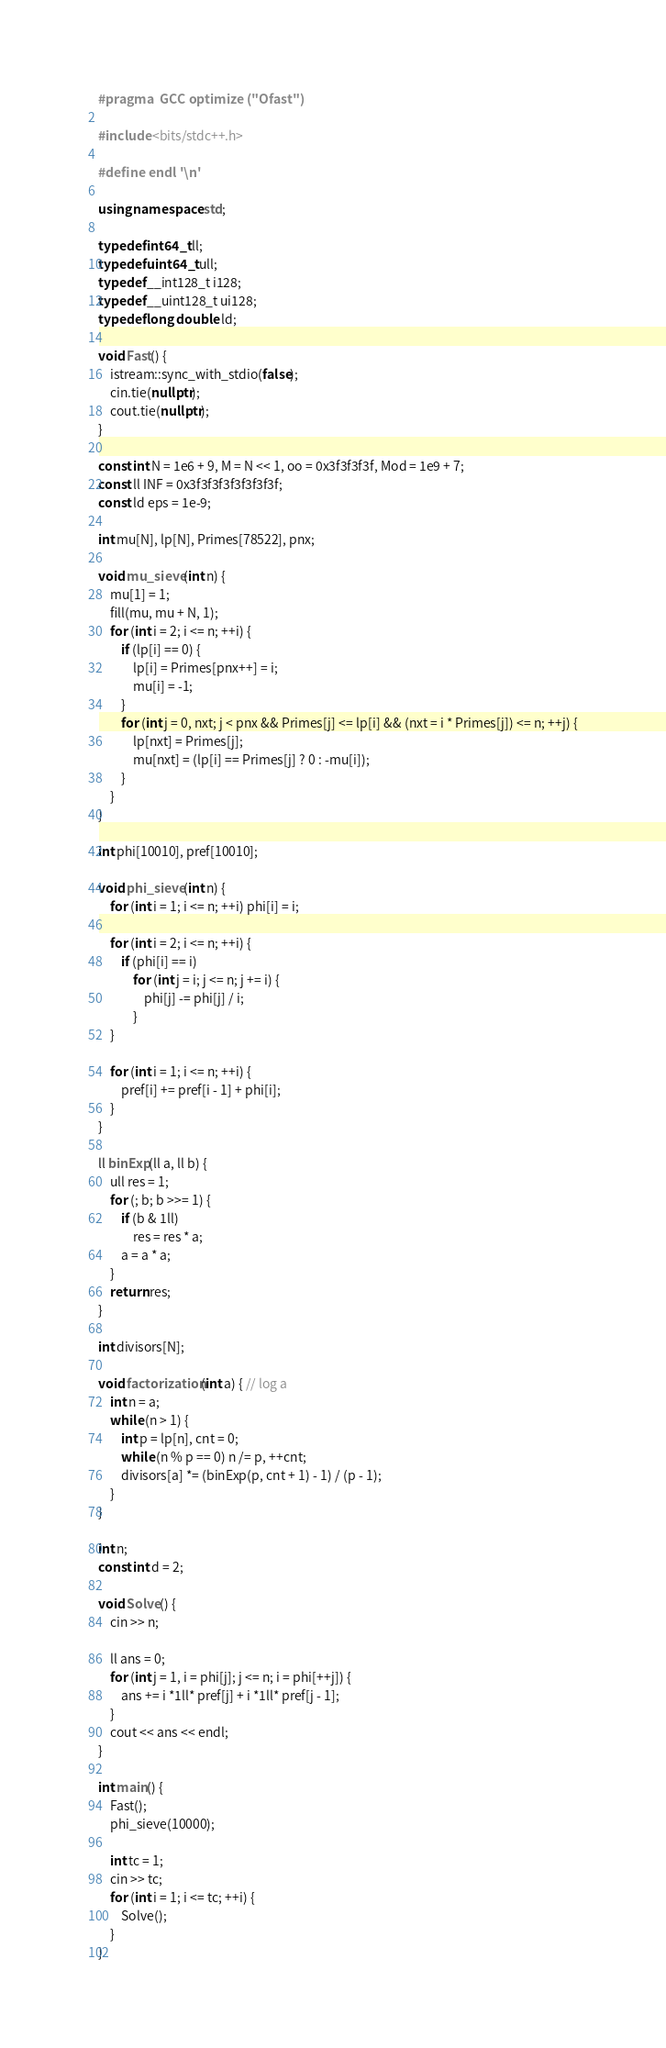Convert code to text. <code><loc_0><loc_0><loc_500><loc_500><_C++_>#pragma  GCC optimize ("Ofast")

#include <bits/stdc++.h>

#define endl '\n'

using namespace std;

typedef int64_t ll;
typedef uint64_t ull;
typedef __int128_t i128;
typedef __uint128_t ui128;
typedef long double ld;

void Fast() {
    istream::sync_with_stdio(false);
    cin.tie(nullptr);
    cout.tie(nullptr);
}

const int N = 1e6 + 9, M = N << 1, oo = 0x3f3f3f3f, Mod = 1e9 + 7;
const ll INF = 0x3f3f3f3f3f3f3f3f;
const ld eps = 1e-9;

int mu[N], lp[N], Primes[78522], pnx;

void mu_sieve(int n) {
    mu[1] = 1;
    fill(mu, mu + N, 1);
    for (int i = 2; i <= n; ++i) {
        if (lp[i] == 0) {
            lp[i] = Primes[pnx++] = i;
            mu[i] = -1;
        }
        for (int j = 0, nxt; j < pnx && Primes[j] <= lp[i] && (nxt = i * Primes[j]) <= n; ++j) {
            lp[nxt] = Primes[j];
            mu[nxt] = (lp[i] == Primes[j] ? 0 : -mu[i]);
        }
    }
}

int phi[10010], pref[10010];

void phi_sieve(int n) {
    for (int i = 1; i <= n; ++i) phi[i] = i;

    for (int i = 2; i <= n; ++i) {
        if (phi[i] == i)
            for (int j = i; j <= n; j += i) {
                phi[j] -= phi[j] / i;
            }
    }

    for (int i = 1; i <= n; ++i) {
        pref[i] += pref[i - 1] + phi[i];
    }
}

ll binExp(ll a, ll b) {
    ull res = 1;
    for (; b; b >>= 1) {
        if (b & 1ll)
            res = res * a;
        a = a * a;
    }
    return res;
}

int divisors[N];

void factorization(int a) { // log a
    int n = a;
    while (n > 1) {
        int p = lp[n], cnt = 0;
        while (n % p == 0) n /= p, ++cnt;
        divisors[a] *= (binExp(p, cnt + 1) - 1) / (p - 1);
    }
}

int n;
const int d = 2;

void Solve() {
    cin >> n;

    ll ans = 0;
    for (int j = 1, i = phi[j]; j <= n; i = phi[++j]) {
        ans += i *1ll* pref[j] + i *1ll* pref[j - 1];
    }
    cout << ans << endl;
}

int main() {
    Fast();
    phi_sieve(10000);

    int tc = 1;
    cin >> tc;
    for (int i = 1; i <= tc; ++i) {
        Solve();
    }
}
</code> 